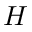Convert formula to latex. <formula><loc_0><loc_0><loc_500><loc_500>H</formula> 